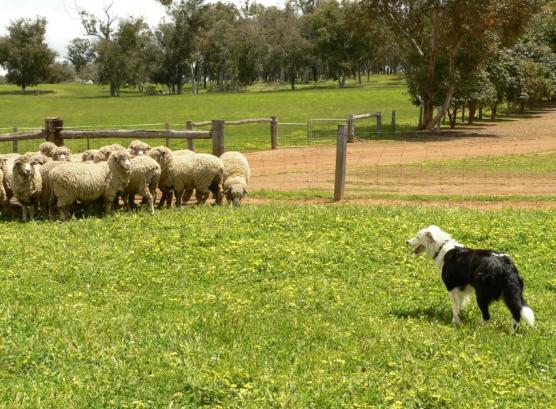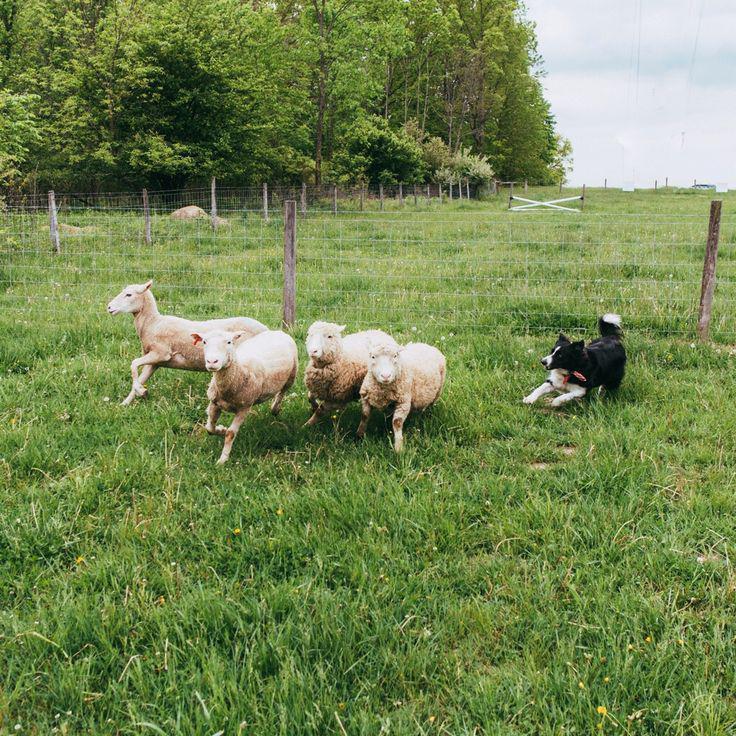The first image is the image on the left, the second image is the image on the right. Given the left and right images, does the statement "Pictures contain a black dog herding sheep." hold true? Answer yes or no. Yes. The first image is the image on the left, the second image is the image on the right. Examine the images to the left and right. Is the description "The human in one of the images is wearing a baseball cap." accurate? Answer yes or no. No. 